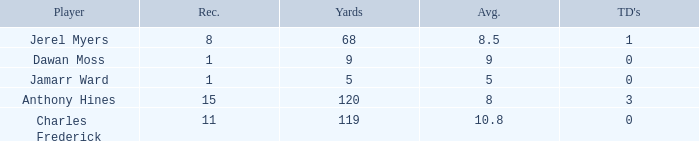What is the average number of TDs when the yards are less than 119, the AVG is larger than 5, and Jamarr Ward is a player? None. 